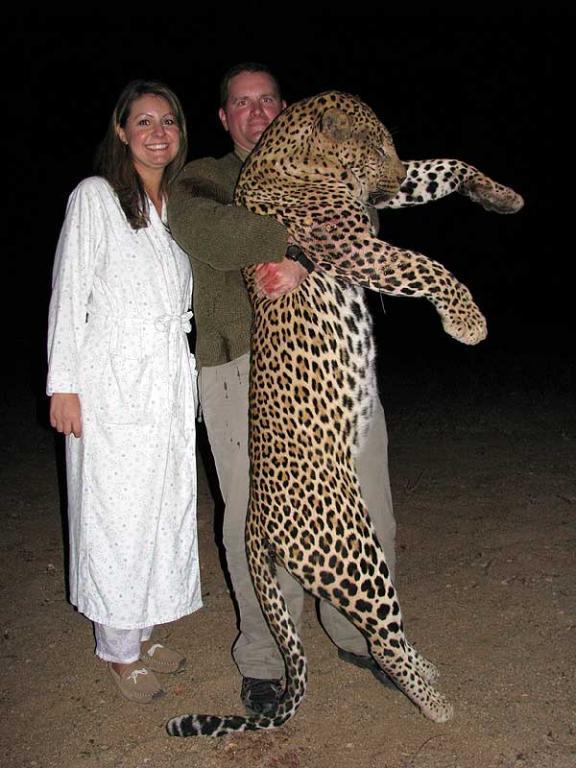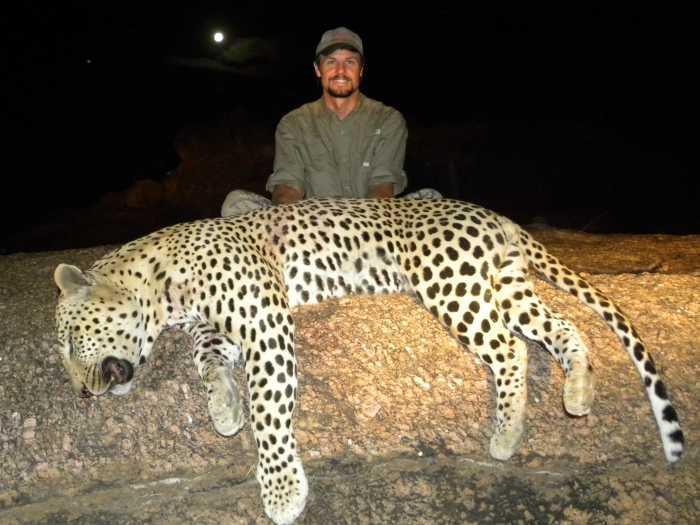The first image is the image on the left, the second image is the image on the right. Given the left and right images, does the statement "A man is holding the cat in one of the images upright." hold true? Answer yes or no. Yes. 